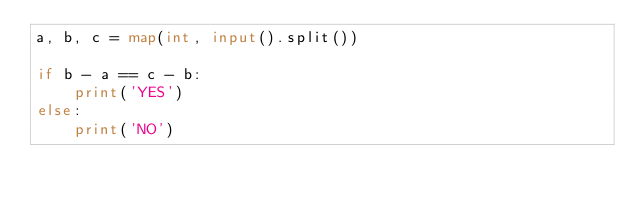Convert code to text. <code><loc_0><loc_0><loc_500><loc_500><_Python_>a, b, c = map(int, input().split())

if b - a == c - b:
    print('YES')
else:
    print('NO')</code> 